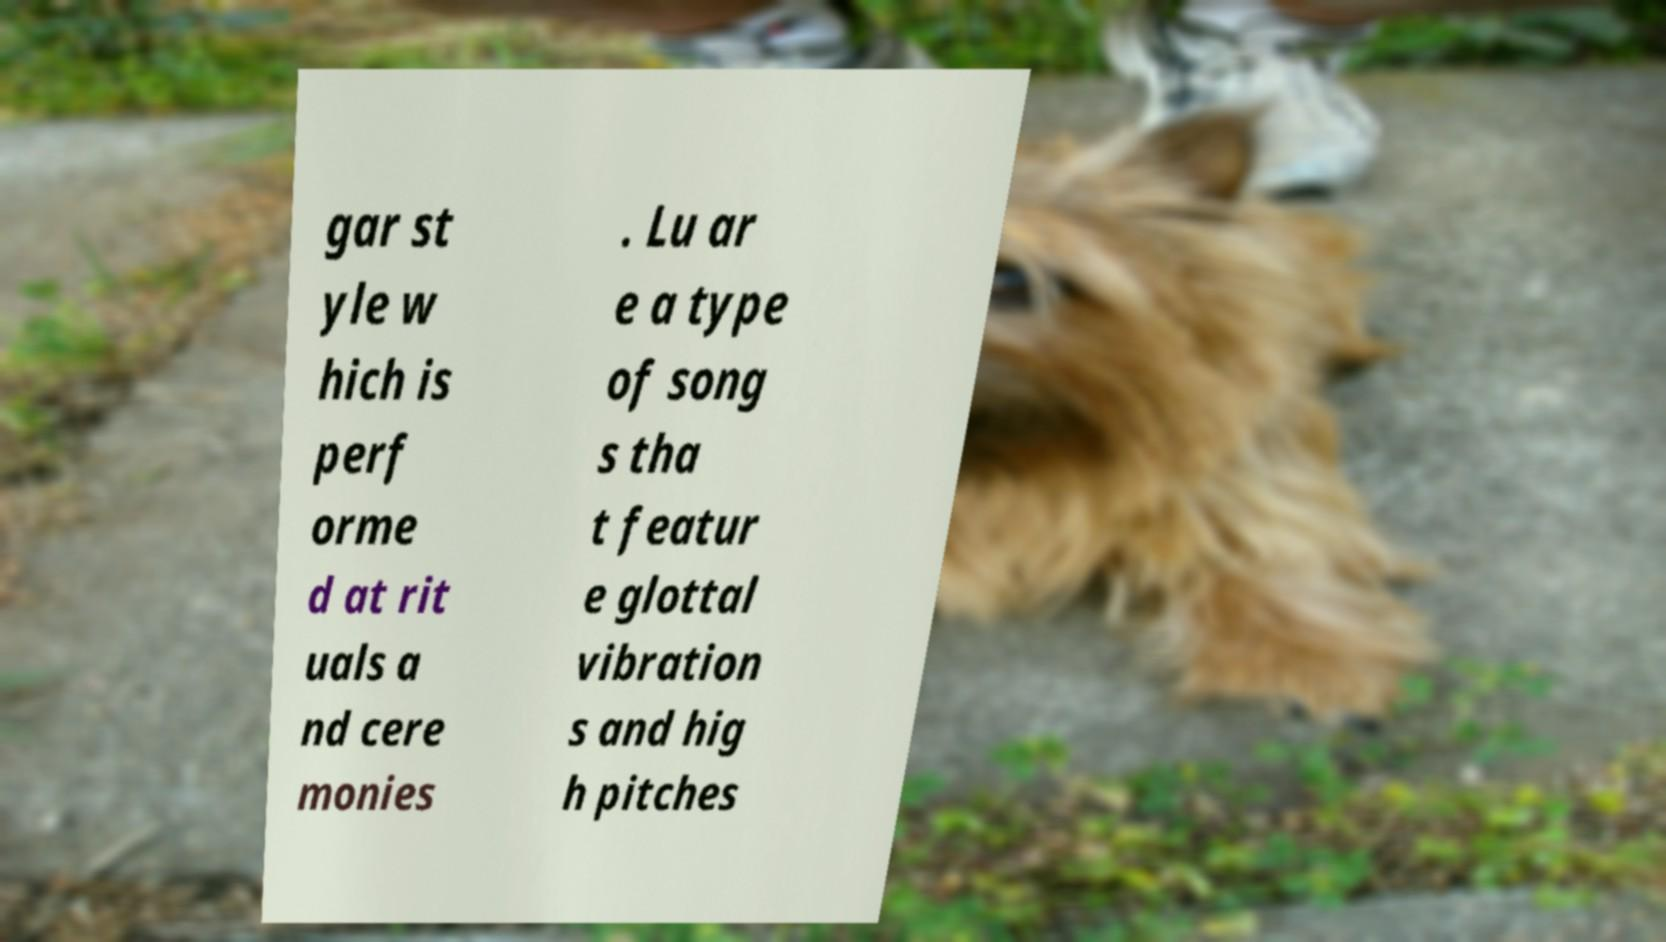Could you extract and type out the text from this image? gar st yle w hich is perf orme d at rit uals a nd cere monies . Lu ar e a type of song s tha t featur e glottal vibration s and hig h pitches 